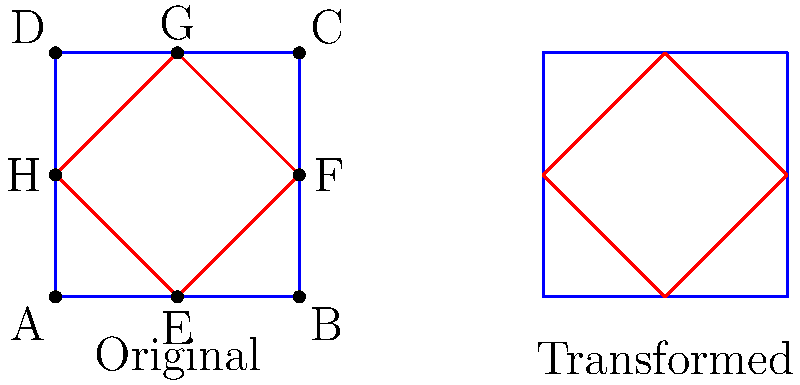You're tasked with creating a symmetrical game logo using transformations and reflections. The original logo consists of a blue square with a red diamond inside. To create perfect symmetry, you need to apply a transformation to the red diamond. Which transformation would you use to achieve the result shown in the right part of the image? To solve this problem, let's analyze the original and transformed logos step-by-step:

1. The original logo (left side):
   - Blue square ABCD
   - Red diamond EFGH inside the square

2. The transformed logo (right side):
   - Blue square remains unchanged
   - Red diamond has been modified

3. Observe the changes in the red diamond:
   - The diamond appears to be flipped horizontally
   - Its position relative to the blue square has changed

4. Identify the line of reflection:
   - The vertical line passing through points E and G (midpoints of AB and DC respectively) seems to be the axis of reflection

5. Apply the transformation:
   - Reflect the red diamond across the line EG
   - This operation is known as a reflection or mirror transformation

6. Verify the result:
   - The transformed diamond in the right logo matches the result of reflecting the original diamond across line EG

Therefore, the transformation used is a reflection (or mirror transformation) across the vertical line passing through points E and G.
Answer: Reflection across the vertical line EG 